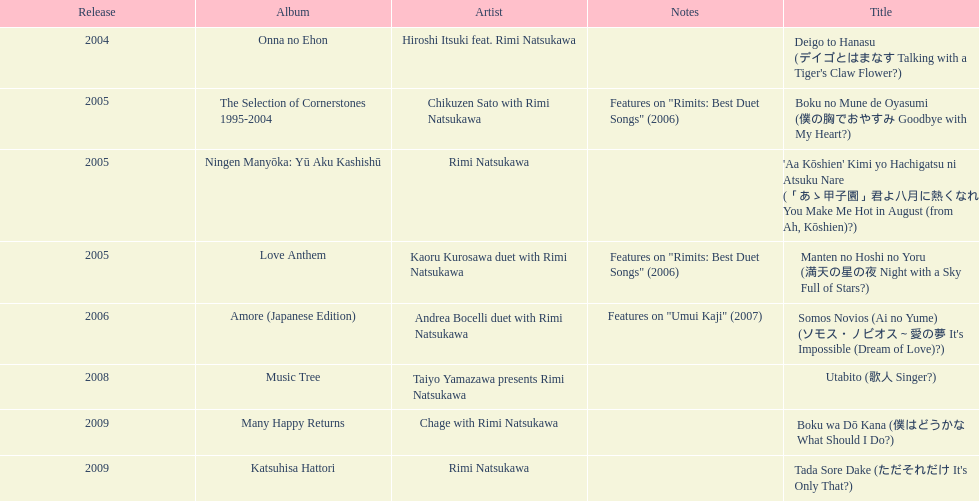What song was this artist on after utabito? Boku wa Dō Kana. 